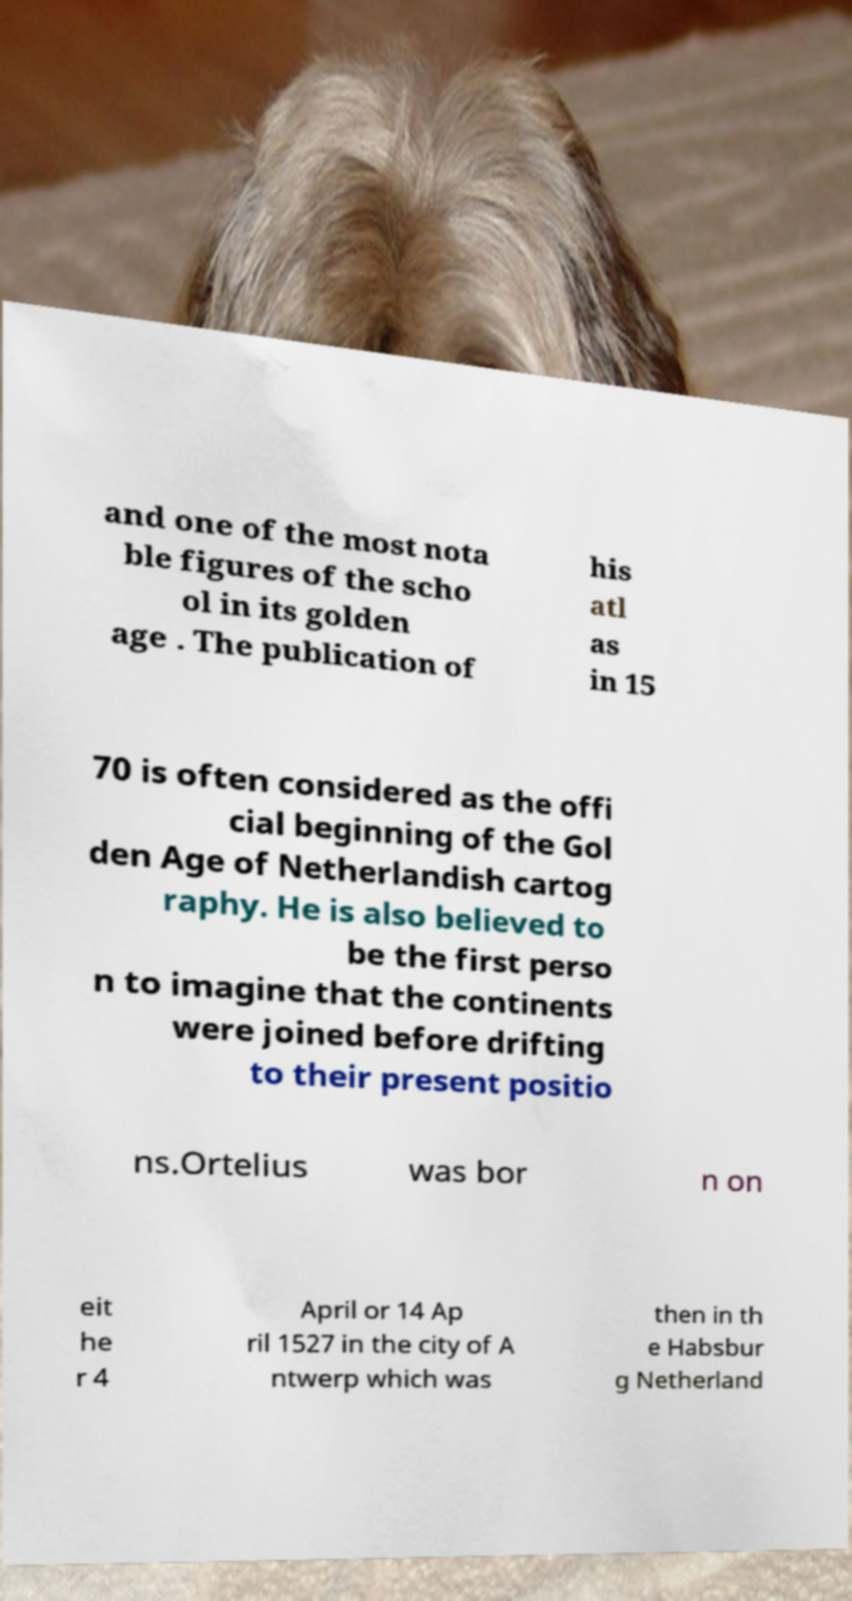I need the written content from this picture converted into text. Can you do that? and one of the most nota ble figures of the scho ol in its golden age . The publication of his atl as in 15 70 is often considered as the offi cial beginning of the Gol den Age of Netherlandish cartog raphy. He is also believed to be the first perso n to imagine that the continents were joined before drifting to their present positio ns.Ortelius was bor n on eit he r 4 April or 14 Ap ril 1527 in the city of A ntwerp which was then in th e Habsbur g Netherland 